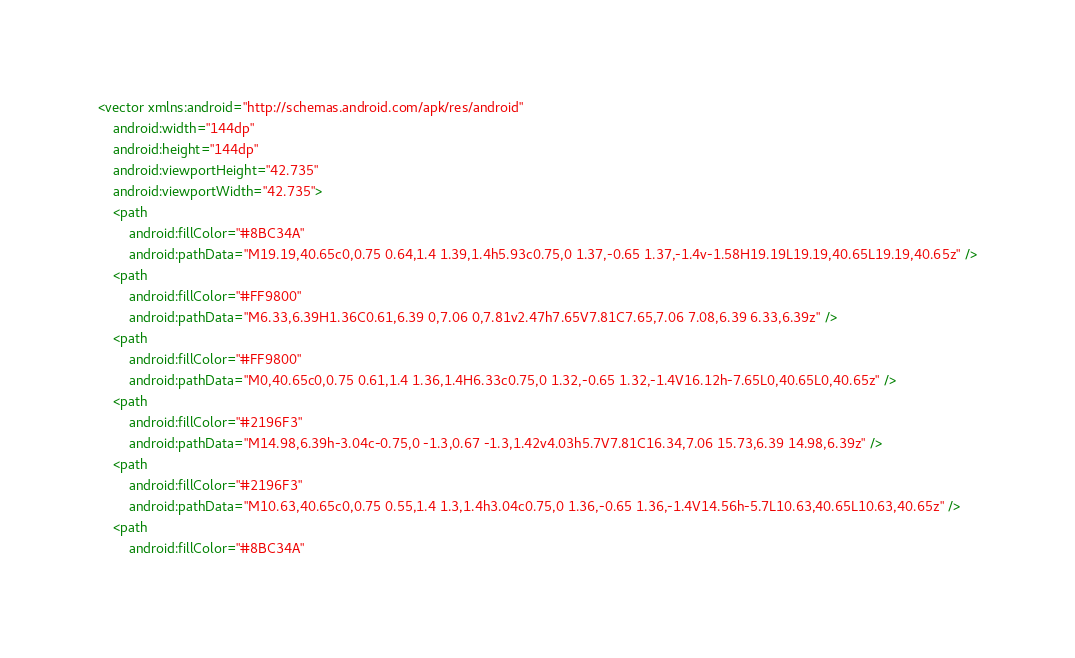Convert code to text. <code><loc_0><loc_0><loc_500><loc_500><_XML_><vector xmlns:android="http://schemas.android.com/apk/res/android"
    android:width="144dp"
    android:height="144dp"
    android:viewportHeight="42.735"
    android:viewportWidth="42.735">
    <path
        android:fillColor="#8BC34A"
        android:pathData="M19.19,40.65c0,0.75 0.64,1.4 1.39,1.4h5.93c0.75,0 1.37,-0.65 1.37,-1.4v-1.58H19.19L19.19,40.65L19.19,40.65z" />
    <path
        android:fillColor="#FF9800"
        android:pathData="M6.33,6.39H1.36C0.61,6.39 0,7.06 0,7.81v2.47h7.65V7.81C7.65,7.06 7.08,6.39 6.33,6.39z" />
    <path
        android:fillColor="#FF9800"
        android:pathData="M0,40.65c0,0.75 0.61,1.4 1.36,1.4H6.33c0.75,0 1.32,-0.65 1.32,-1.4V16.12h-7.65L0,40.65L0,40.65z" />
    <path
        android:fillColor="#2196F3"
        android:pathData="M14.98,6.39h-3.04c-0.75,0 -1.3,0.67 -1.3,1.42v4.03h5.7V7.81C16.34,7.06 15.73,6.39 14.98,6.39z" />
    <path
        android:fillColor="#2196F3"
        android:pathData="M10.63,40.65c0,0.75 0.55,1.4 1.3,1.4h3.04c0.75,0 1.36,-0.65 1.36,-1.4V14.56h-5.7L10.63,40.65L10.63,40.65z" />
    <path
        android:fillColor="#8BC34A"</code> 